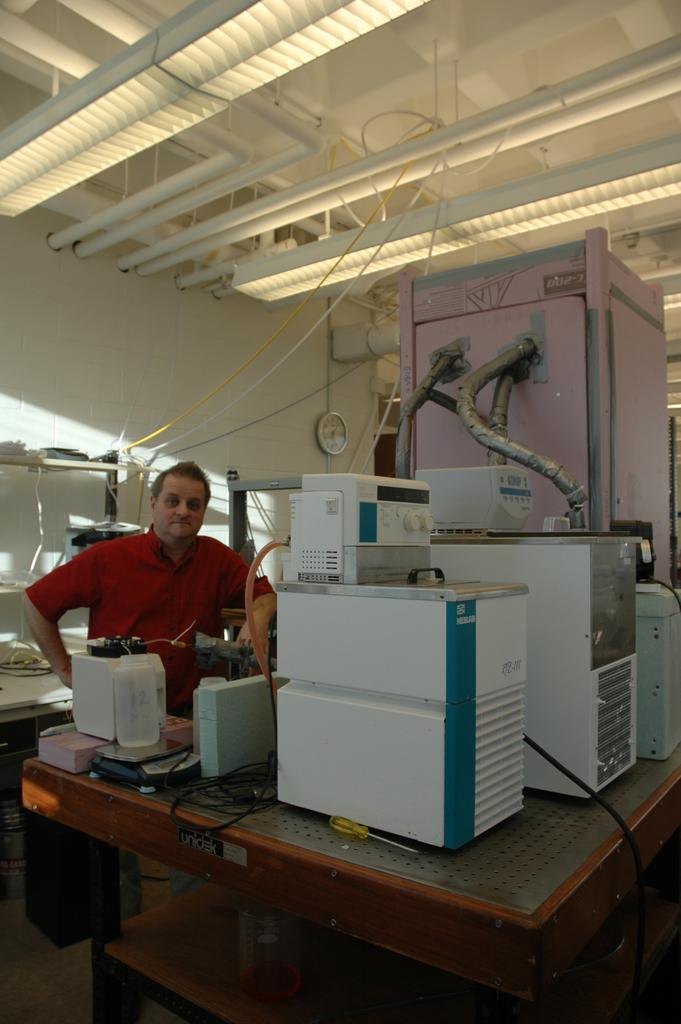What is the man in the image doing? The provided facts do not specify what the man is doing, so we cannot definitively answer this question. What color is the shirt the man is wearing? The man is wearing a red shirt. What can be seen on the wall in the background of the image? There is a clock on the wall in the background. What objects are on the table in the image? There are machines on a table in the image. What type of paste is the man using to roll out dough in the image? There is no dough or paste present in the image, and the man is not shown performing any activity related to rolling or dough. 